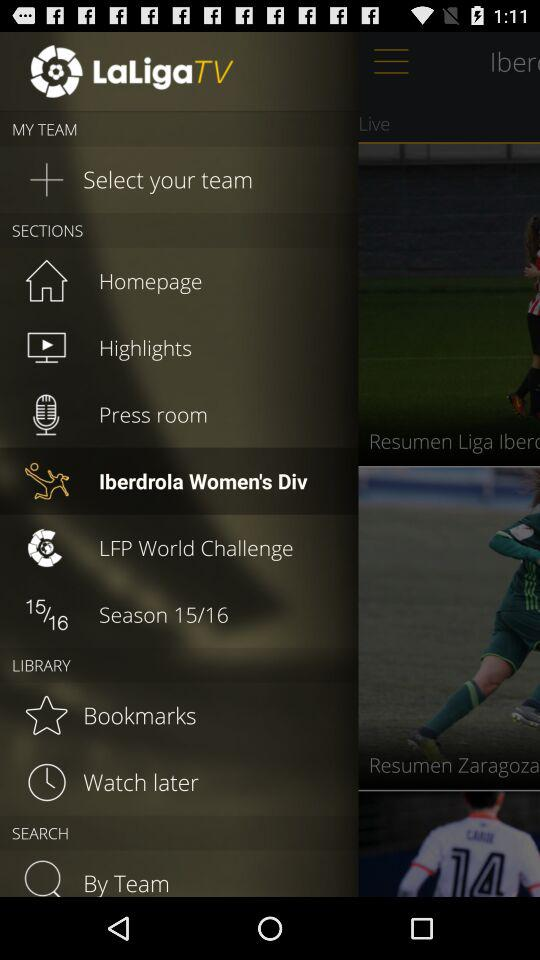Which season is mentioned? The mentioned season is from 2015 to 2016. 